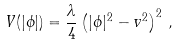Convert formula to latex. <formula><loc_0><loc_0><loc_500><loc_500>V ( | \phi | ) = \frac { \lambda } { 4 } \left ( | \phi | ^ { 2 } - v ^ { 2 } \right ) ^ { 2 } \, ,</formula> 